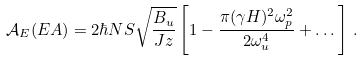<formula> <loc_0><loc_0><loc_500><loc_500>\mathcal { A } _ { E } ( E A ) = 2 \hbar { N } S \sqrt { \frac { B _ { u } } { J z } } \left [ 1 - \frac { \pi ( \gamma H ) ^ { 2 } \omega _ { p } ^ { 2 } } { 2 \omega _ { u } ^ { 4 } } + \dots \right ] \, .</formula> 